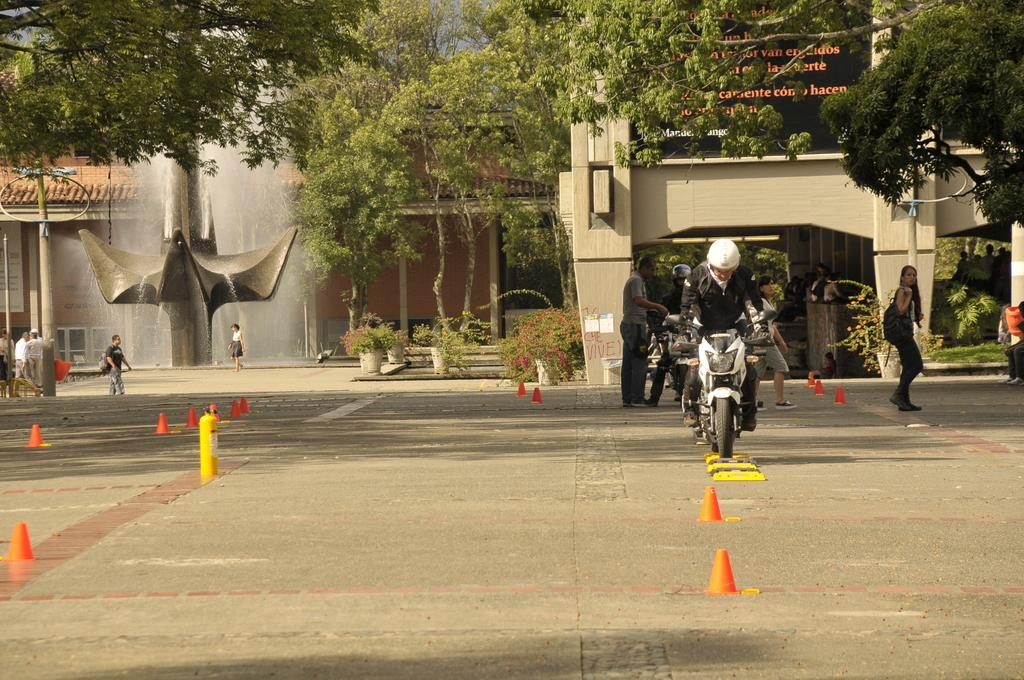What is the man in the image doing? The man is riding a bike in the image. Where is the man riding the bike? The man is on the road. What can be seen in the background of the image? There is a lady walking, men standing, a tree, a building, and a waterfall in the background of the image. What is the man teaching in the image? There is no indication in the image that the man is teaching anything. What type of flag is visible in the image? There is no flag present in the image. 